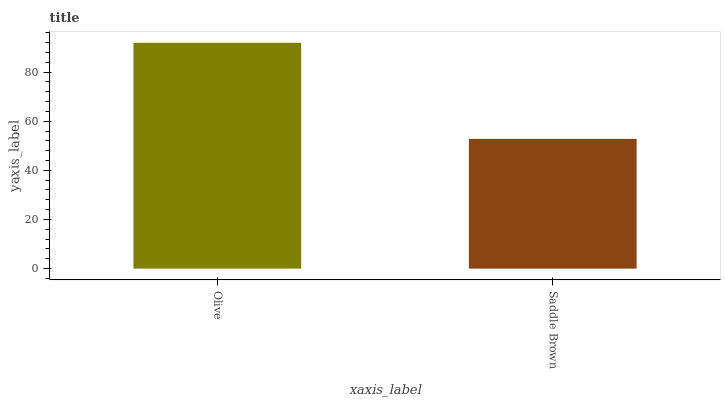Is Saddle Brown the minimum?
Answer yes or no. Yes. Is Olive the maximum?
Answer yes or no. Yes. Is Saddle Brown the maximum?
Answer yes or no. No. Is Olive greater than Saddle Brown?
Answer yes or no. Yes. Is Saddle Brown less than Olive?
Answer yes or no. Yes. Is Saddle Brown greater than Olive?
Answer yes or no. No. Is Olive less than Saddle Brown?
Answer yes or no. No. Is Olive the high median?
Answer yes or no. Yes. Is Saddle Brown the low median?
Answer yes or no. Yes. Is Saddle Brown the high median?
Answer yes or no. No. Is Olive the low median?
Answer yes or no. No. 